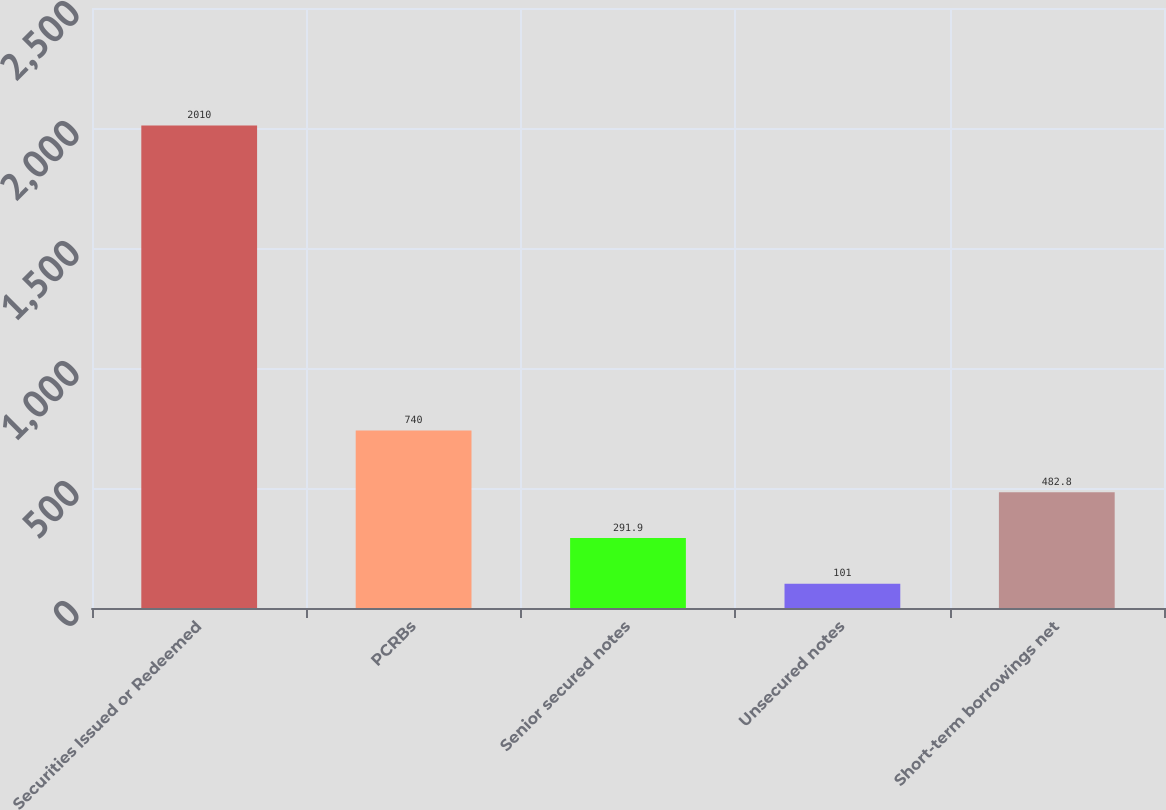Convert chart to OTSL. <chart><loc_0><loc_0><loc_500><loc_500><bar_chart><fcel>Securities Issued or Redeemed<fcel>PCRBs<fcel>Senior secured notes<fcel>Unsecured notes<fcel>Short-term borrowings net<nl><fcel>2010<fcel>740<fcel>291.9<fcel>101<fcel>482.8<nl></chart> 